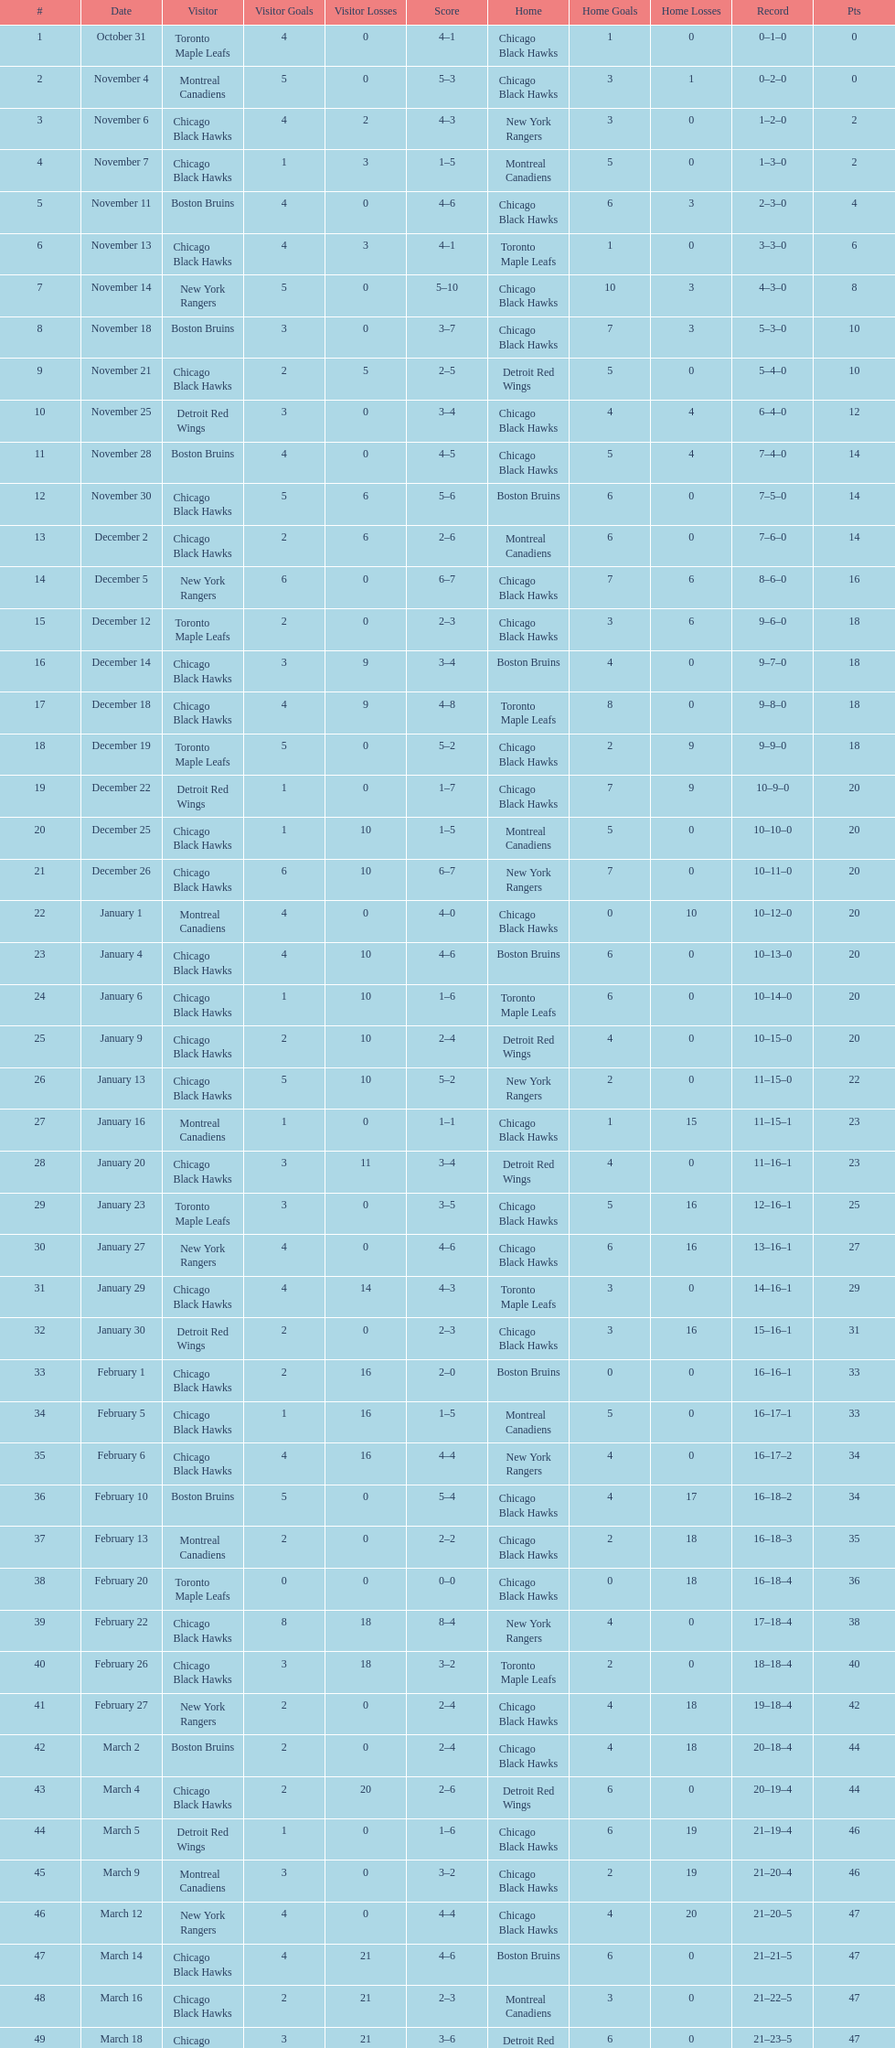Who were the opponents of the boston bruins in their game after november 11? Chicago Black Hawks. 